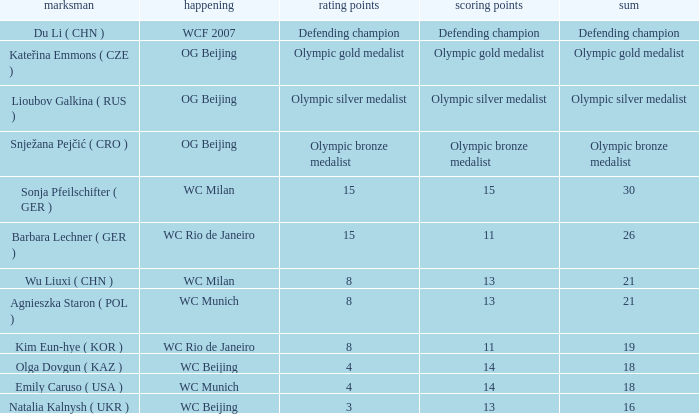Which event had a total of defending champion? WCF 2007. 